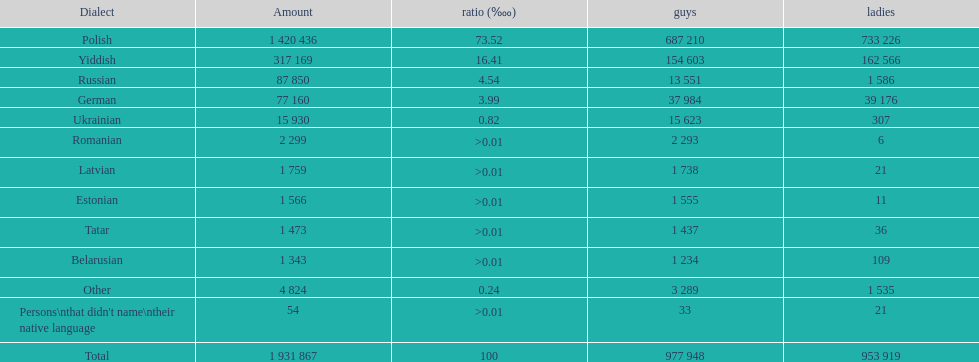What was the next most commonly spoken language in poland after russian? German. 